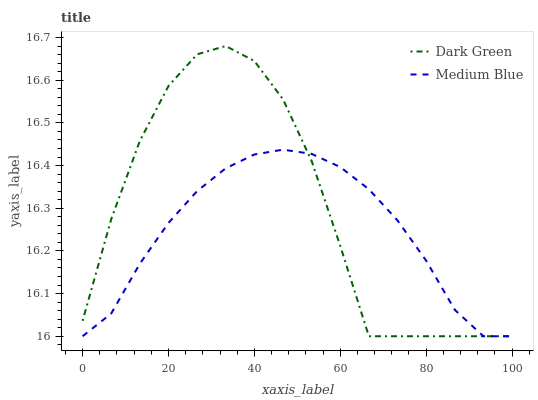Does Medium Blue have the minimum area under the curve?
Answer yes or no. Yes. Does Dark Green have the maximum area under the curve?
Answer yes or no. Yes. Does Dark Green have the minimum area under the curve?
Answer yes or no. No. Is Medium Blue the smoothest?
Answer yes or no. Yes. Is Dark Green the roughest?
Answer yes or no. Yes. Is Dark Green the smoothest?
Answer yes or no. No. Does Medium Blue have the lowest value?
Answer yes or no. Yes. Does Dark Green have the highest value?
Answer yes or no. Yes. Does Dark Green intersect Medium Blue?
Answer yes or no. Yes. Is Dark Green less than Medium Blue?
Answer yes or no. No. Is Dark Green greater than Medium Blue?
Answer yes or no. No. 